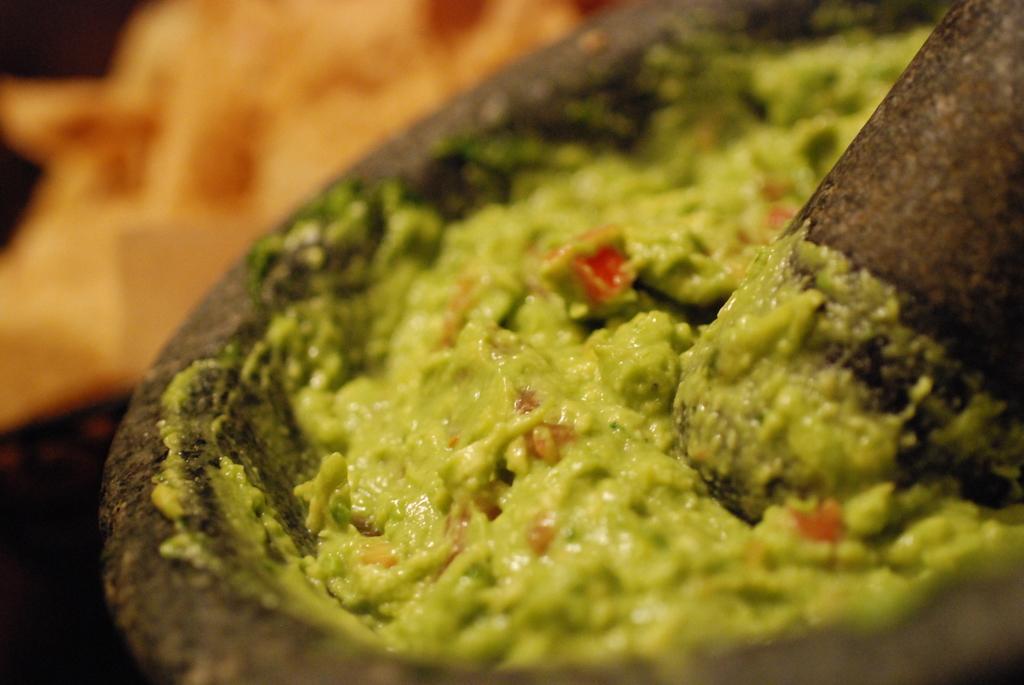Describe this image in one or two sentences. In this image, this looks like a food item, which is green in color. This looks like a grinding stone. The background looks blurry. 